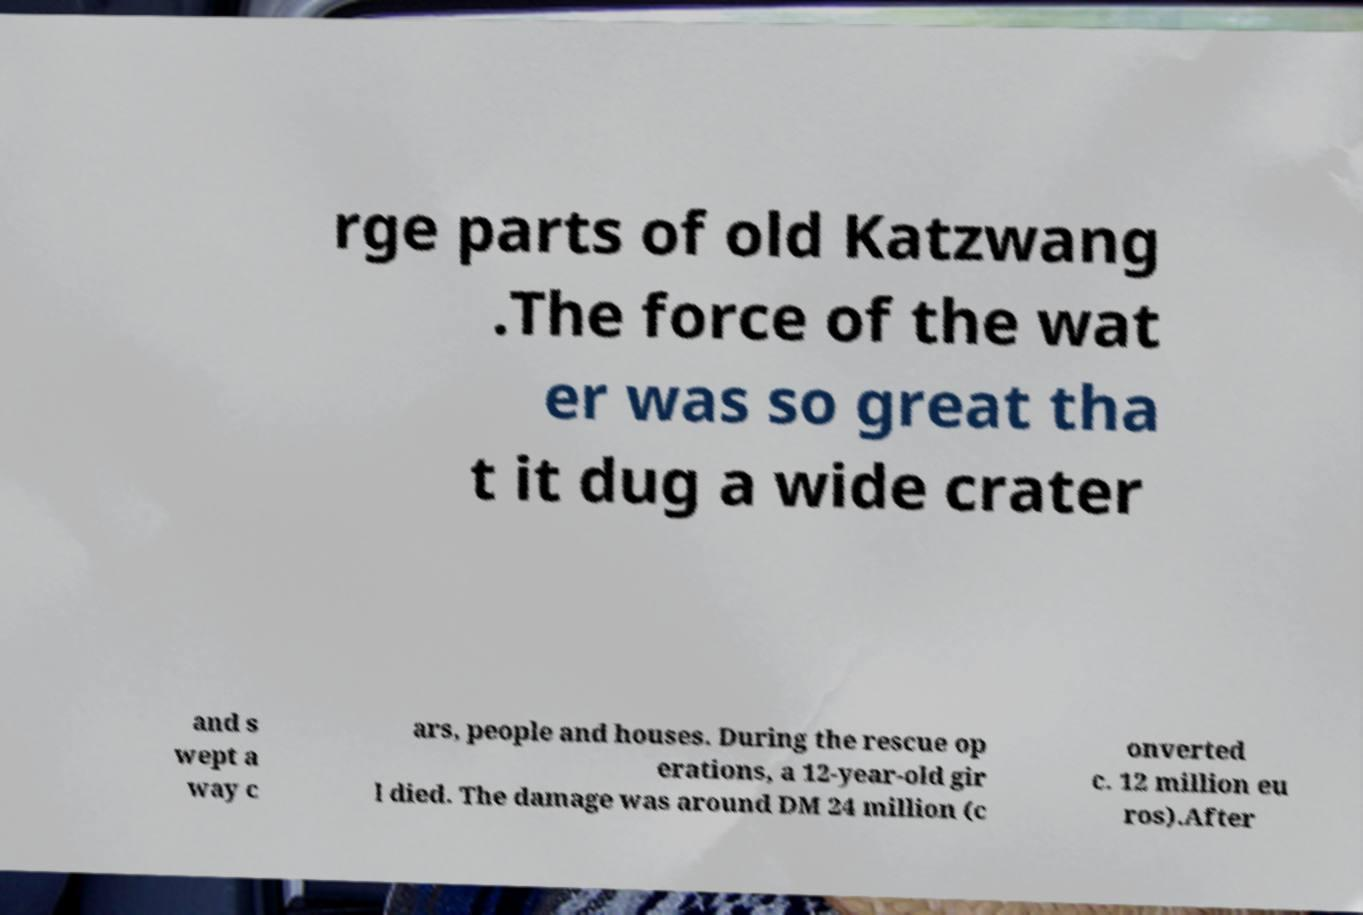For documentation purposes, I need the text within this image transcribed. Could you provide that? rge parts of old Katzwang .The force of the wat er was so great tha t it dug a wide crater and s wept a way c ars, people and houses. During the rescue op erations, a 12-year-old gir l died. The damage was around DM 24 million (c onverted c. 12 million eu ros).After 